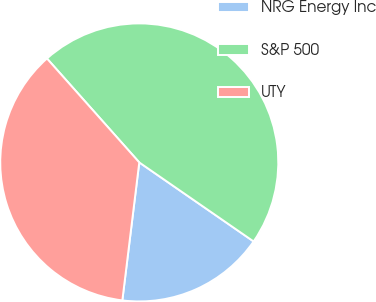<chart> <loc_0><loc_0><loc_500><loc_500><pie_chart><fcel>NRG Energy Inc<fcel>S&P 500<fcel>UTY<nl><fcel>17.32%<fcel>46.19%<fcel>36.5%<nl></chart> 